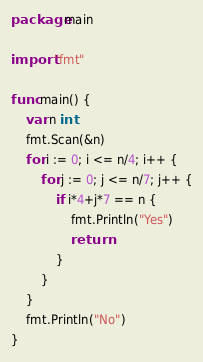<code> <loc_0><loc_0><loc_500><loc_500><_Go_>package main

import "fmt"

func main() {
	var n int
	fmt.Scan(&n)
	for i := 0; i <= n/4; i++ {
		for j := 0; j <= n/7; j++ {
			if i*4+j*7 == n {
				fmt.Println("Yes")
				return
			}
		}
	}
	fmt.Println("No")
}
</code> 